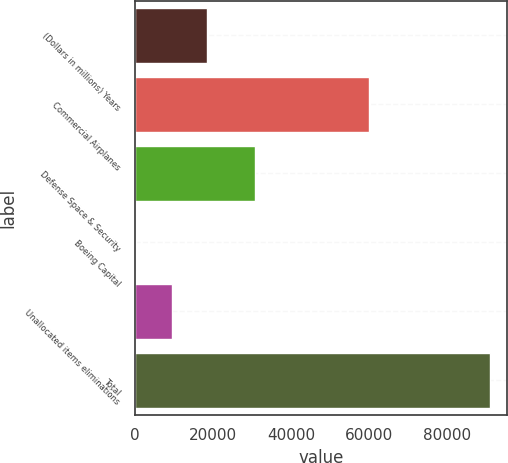Convert chart to OTSL. <chart><loc_0><loc_0><loc_500><loc_500><bar_chart><fcel>(Dollars in millions) Years<fcel>Commercial Airplanes<fcel>Defense Space & Security<fcel>Boeing Capital<fcel>Unallocated items eliminations<fcel>Total<nl><fcel>18485.2<fcel>59990<fcel>30881<fcel>416<fcel>9450.6<fcel>90762<nl></chart> 